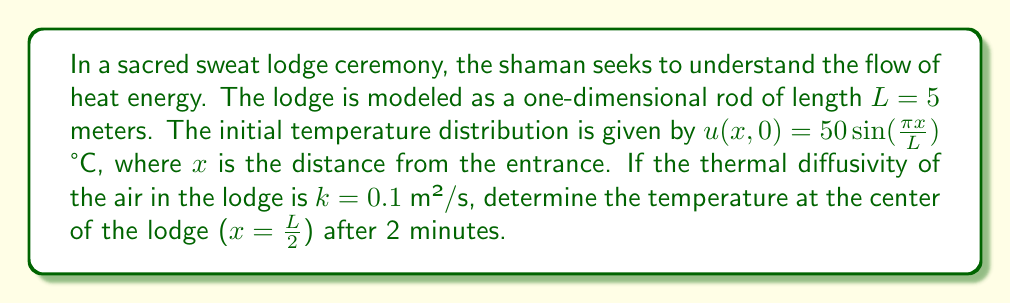Show me your answer to this math problem. To solve this problem, we'll use the heat equation in one dimension:

$$\frac{\partial u}{\partial t} = k\frac{\partial^2 u}{\partial x^2}$$

Given:
- Initial condition: $u(x,0) = 50 \sin(\frac{\pi x}{L})$
- Boundary conditions: $u(0,t) = u(L,t) = 0$ (implied by the sinusoidal distribution)
- $L = 5$ m
- $k = 0.1$ m²/s
- $t = 2$ minutes = 120 seconds

Step 1: The solution to the heat equation with these conditions is of the form:
$$u(x,t) = A e^{-\alpha t} \sin(\frac{\pi x}{L})$$

Where $A$ is the amplitude and $\alpha$ is the decay constant.

Step 2: From the initial condition, we can see that $A = 50$.

Step 3: The decay constant $\alpha$ is given by:
$$\alpha = k(\frac{\pi}{L})^2$$

Step 4: Calculate $\alpha$:
$$\alpha = 0.1 (\frac{\pi}{5})^2 = 0.0394\text{ s}^{-1}$$

Step 5: Now we can write the full solution:
$$u(x,t) = 50 e^{-0.0394t} \sin(\frac{\pi x}{L})$$

Step 6: To find the temperature at the center after 2 minutes, we substitute $x = \frac{L}{2} = 2.5$ m and $t = 120$ s:

$$u(2.5, 120) = 50 e^{-0.0394 \cdot 120} \sin(\frac{\pi \cdot 2.5}{5})$$

Step 7: Simplify:
$$u(2.5, 120) = 50 e^{-4.728} \sin(\frac{\pi}{2}) = 50 \cdot 0.0088 \cdot 1 = 0.44\text{ °C}$$
Answer: 0.44 °C 